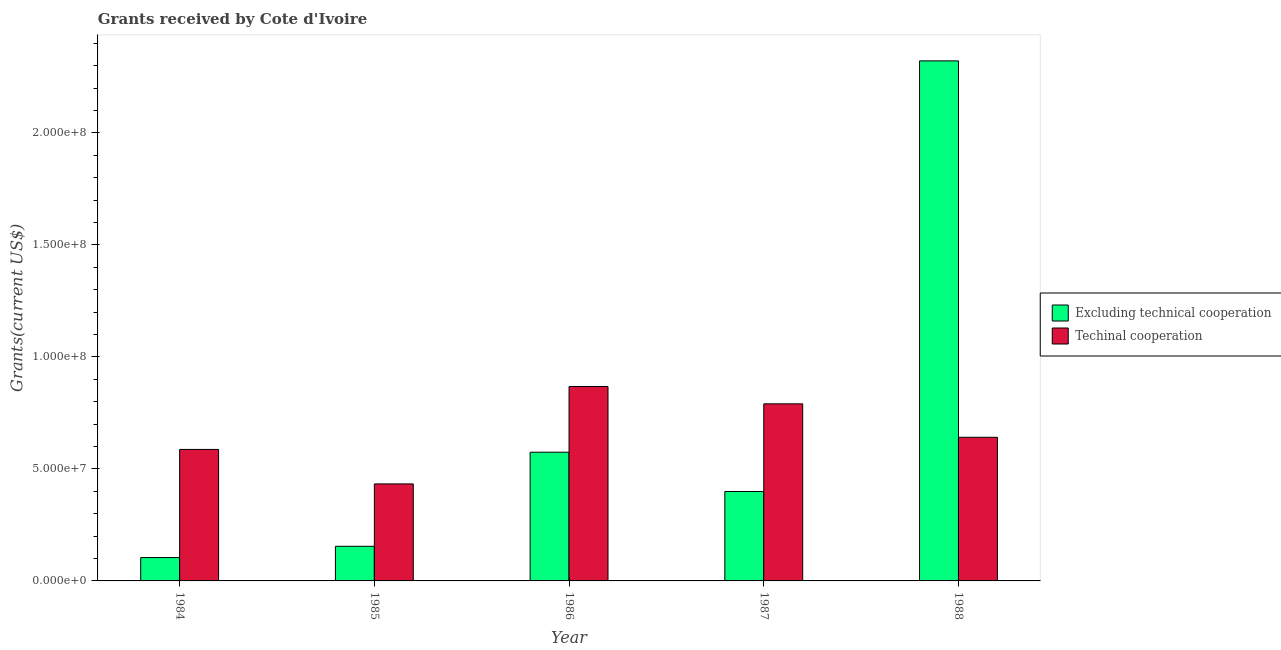How many different coloured bars are there?
Your answer should be compact. 2. How many groups of bars are there?
Your response must be concise. 5. Are the number of bars per tick equal to the number of legend labels?
Ensure brevity in your answer.  Yes. How many bars are there on the 2nd tick from the left?
Give a very brief answer. 2. How many bars are there on the 3rd tick from the right?
Provide a short and direct response. 2. In how many cases, is the number of bars for a given year not equal to the number of legend labels?
Offer a very short reply. 0. What is the amount of grants received(including technical cooperation) in 1985?
Make the answer very short. 4.33e+07. Across all years, what is the maximum amount of grants received(including technical cooperation)?
Ensure brevity in your answer.  8.68e+07. Across all years, what is the minimum amount of grants received(including technical cooperation)?
Give a very brief answer. 4.33e+07. In which year was the amount of grants received(excluding technical cooperation) minimum?
Offer a very short reply. 1984. What is the total amount of grants received(including technical cooperation) in the graph?
Your response must be concise. 3.32e+08. What is the difference between the amount of grants received(excluding technical cooperation) in 1987 and that in 1988?
Offer a terse response. -1.92e+08. What is the difference between the amount of grants received(including technical cooperation) in 1988 and the amount of grants received(excluding technical cooperation) in 1987?
Your response must be concise. -1.49e+07. What is the average amount of grants received(excluding technical cooperation) per year?
Make the answer very short. 7.11e+07. What is the ratio of the amount of grants received(excluding technical cooperation) in 1985 to that in 1986?
Offer a very short reply. 0.27. What is the difference between the highest and the second highest amount of grants received(including technical cooperation)?
Your response must be concise. 7.74e+06. What is the difference between the highest and the lowest amount of grants received(excluding technical cooperation)?
Ensure brevity in your answer.  2.22e+08. What does the 1st bar from the left in 1987 represents?
Give a very brief answer. Excluding technical cooperation. What does the 1st bar from the right in 1988 represents?
Provide a short and direct response. Techinal cooperation. How many bars are there?
Your answer should be compact. 10. Are all the bars in the graph horizontal?
Your answer should be compact. No. How many years are there in the graph?
Ensure brevity in your answer.  5. How are the legend labels stacked?
Ensure brevity in your answer.  Vertical. What is the title of the graph?
Give a very brief answer. Grants received by Cote d'Ivoire. Does "Resident workers" appear as one of the legend labels in the graph?
Give a very brief answer. No. What is the label or title of the X-axis?
Make the answer very short. Year. What is the label or title of the Y-axis?
Ensure brevity in your answer.  Grants(current US$). What is the Grants(current US$) in Excluding technical cooperation in 1984?
Ensure brevity in your answer.  1.04e+07. What is the Grants(current US$) of Techinal cooperation in 1984?
Make the answer very short. 5.87e+07. What is the Grants(current US$) of Excluding technical cooperation in 1985?
Provide a succinct answer. 1.55e+07. What is the Grants(current US$) in Techinal cooperation in 1985?
Make the answer very short. 4.33e+07. What is the Grants(current US$) of Excluding technical cooperation in 1986?
Offer a very short reply. 5.74e+07. What is the Grants(current US$) in Techinal cooperation in 1986?
Keep it short and to the point. 8.68e+07. What is the Grants(current US$) in Excluding technical cooperation in 1987?
Your answer should be compact. 3.99e+07. What is the Grants(current US$) of Techinal cooperation in 1987?
Your response must be concise. 7.90e+07. What is the Grants(current US$) in Excluding technical cooperation in 1988?
Your answer should be compact. 2.32e+08. What is the Grants(current US$) in Techinal cooperation in 1988?
Make the answer very short. 6.41e+07. Across all years, what is the maximum Grants(current US$) of Excluding technical cooperation?
Offer a very short reply. 2.32e+08. Across all years, what is the maximum Grants(current US$) in Techinal cooperation?
Your response must be concise. 8.68e+07. Across all years, what is the minimum Grants(current US$) in Excluding technical cooperation?
Your answer should be compact. 1.04e+07. Across all years, what is the minimum Grants(current US$) in Techinal cooperation?
Your response must be concise. 4.33e+07. What is the total Grants(current US$) of Excluding technical cooperation in the graph?
Provide a succinct answer. 3.55e+08. What is the total Grants(current US$) in Techinal cooperation in the graph?
Your answer should be very brief. 3.32e+08. What is the difference between the Grants(current US$) in Excluding technical cooperation in 1984 and that in 1985?
Make the answer very short. -5.03e+06. What is the difference between the Grants(current US$) in Techinal cooperation in 1984 and that in 1985?
Your answer should be very brief. 1.54e+07. What is the difference between the Grants(current US$) of Excluding technical cooperation in 1984 and that in 1986?
Offer a very short reply. -4.70e+07. What is the difference between the Grants(current US$) in Techinal cooperation in 1984 and that in 1986?
Offer a very short reply. -2.81e+07. What is the difference between the Grants(current US$) in Excluding technical cooperation in 1984 and that in 1987?
Your response must be concise. -2.95e+07. What is the difference between the Grants(current US$) in Techinal cooperation in 1984 and that in 1987?
Your answer should be very brief. -2.04e+07. What is the difference between the Grants(current US$) in Excluding technical cooperation in 1984 and that in 1988?
Offer a terse response. -2.22e+08. What is the difference between the Grants(current US$) of Techinal cooperation in 1984 and that in 1988?
Offer a very short reply. -5.42e+06. What is the difference between the Grants(current US$) of Excluding technical cooperation in 1985 and that in 1986?
Make the answer very short. -4.20e+07. What is the difference between the Grants(current US$) in Techinal cooperation in 1985 and that in 1986?
Ensure brevity in your answer.  -4.35e+07. What is the difference between the Grants(current US$) of Excluding technical cooperation in 1985 and that in 1987?
Offer a terse response. -2.45e+07. What is the difference between the Grants(current US$) in Techinal cooperation in 1985 and that in 1987?
Your answer should be compact. -3.57e+07. What is the difference between the Grants(current US$) in Excluding technical cooperation in 1985 and that in 1988?
Offer a very short reply. -2.17e+08. What is the difference between the Grants(current US$) of Techinal cooperation in 1985 and that in 1988?
Provide a succinct answer. -2.08e+07. What is the difference between the Grants(current US$) of Excluding technical cooperation in 1986 and that in 1987?
Ensure brevity in your answer.  1.75e+07. What is the difference between the Grants(current US$) of Techinal cooperation in 1986 and that in 1987?
Ensure brevity in your answer.  7.74e+06. What is the difference between the Grants(current US$) of Excluding technical cooperation in 1986 and that in 1988?
Your answer should be compact. -1.75e+08. What is the difference between the Grants(current US$) of Techinal cooperation in 1986 and that in 1988?
Keep it short and to the point. 2.27e+07. What is the difference between the Grants(current US$) in Excluding technical cooperation in 1987 and that in 1988?
Keep it short and to the point. -1.92e+08. What is the difference between the Grants(current US$) of Techinal cooperation in 1987 and that in 1988?
Your answer should be compact. 1.49e+07. What is the difference between the Grants(current US$) of Excluding technical cooperation in 1984 and the Grants(current US$) of Techinal cooperation in 1985?
Your response must be concise. -3.29e+07. What is the difference between the Grants(current US$) of Excluding technical cooperation in 1984 and the Grants(current US$) of Techinal cooperation in 1986?
Keep it short and to the point. -7.64e+07. What is the difference between the Grants(current US$) of Excluding technical cooperation in 1984 and the Grants(current US$) of Techinal cooperation in 1987?
Provide a short and direct response. -6.86e+07. What is the difference between the Grants(current US$) of Excluding technical cooperation in 1984 and the Grants(current US$) of Techinal cooperation in 1988?
Provide a succinct answer. -5.37e+07. What is the difference between the Grants(current US$) of Excluding technical cooperation in 1985 and the Grants(current US$) of Techinal cooperation in 1986?
Your response must be concise. -7.13e+07. What is the difference between the Grants(current US$) of Excluding technical cooperation in 1985 and the Grants(current US$) of Techinal cooperation in 1987?
Your answer should be very brief. -6.36e+07. What is the difference between the Grants(current US$) of Excluding technical cooperation in 1985 and the Grants(current US$) of Techinal cooperation in 1988?
Make the answer very short. -4.86e+07. What is the difference between the Grants(current US$) in Excluding technical cooperation in 1986 and the Grants(current US$) in Techinal cooperation in 1987?
Offer a terse response. -2.16e+07. What is the difference between the Grants(current US$) in Excluding technical cooperation in 1986 and the Grants(current US$) in Techinal cooperation in 1988?
Offer a very short reply. -6.66e+06. What is the difference between the Grants(current US$) in Excluding technical cooperation in 1987 and the Grants(current US$) in Techinal cooperation in 1988?
Keep it short and to the point. -2.42e+07. What is the average Grants(current US$) in Excluding technical cooperation per year?
Offer a terse response. 7.11e+07. What is the average Grants(current US$) in Techinal cooperation per year?
Provide a succinct answer. 6.64e+07. In the year 1984, what is the difference between the Grants(current US$) of Excluding technical cooperation and Grants(current US$) of Techinal cooperation?
Your answer should be compact. -4.83e+07. In the year 1985, what is the difference between the Grants(current US$) in Excluding technical cooperation and Grants(current US$) in Techinal cooperation?
Your response must be concise. -2.78e+07. In the year 1986, what is the difference between the Grants(current US$) in Excluding technical cooperation and Grants(current US$) in Techinal cooperation?
Provide a short and direct response. -2.93e+07. In the year 1987, what is the difference between the Grants(current US$) in Excluding technical cooperation and Grants(current US$) in Techinal cooperation?
Offer a terse response. -3.91e+07. In the year 1988, what is the difference between the Grants(current US$) in Excluding technical cooperation and Grants(current US$) in Techinal cooperation?
Offer a very short reply. 1.68e+08. What is the ratio of the Grants(current US$) of Excluding technical cooperation in 1984 to that in 1985?
Provide a succinct answer. 0.67. What is the ratio of the Grants(current US$) in Techinal cooperation in 1984 to that in 1985?
Keep it short and to the point. 1.36. What is the ratio of the Grants(current US$) in Excluding technical cooperation in 1984 to that in 1986?
Give a very brief answer. 0.18. What is the ratio of the Grants(current US$) in Techinal cooperation in 1984 to that in 1986?
Your response must be concise. 0.68. What is the ratio of the Grants(current US$) in Excluding technical cooperation in 1984 to that in 1987?
Provide a short and direct response. 0.26. What is the ratio of the Grants(current US$) of Techinal cooperation in 1984 to that in 1987?
Make the answer very short. 0.74. What is the ratio of the Grants(current US$) of Excluding technical cooperation in 1984 to that in 1988?
Offer a terse response. 0.04. What is the ratio of the Grants(current US$) of Techinal cooperation in 1984 to that in 1988?
Provide a short and direct response. 0.92. What is the ratio of the Grants(current US$) of Excluding technical cooperation in 1985 to that in 1986?
Give a very brief answer. 0.27. What is the ratio of the Grants(current US$) in Techinal cooperation in 1985 to that in 1986?
Provide a succinct answer. 0.5. What is the ratio of the Grants(current US$) of Excluding technical cooperation in 1985 to that in 1987?
Ensure brevity in your answer.  0.39. What is the ratio of the Grants(current US$) of Techinal cooperation in 1985 to that in 1987?
Your answer should be compact. 0.55. What is the ratio of the Grants(current US$) in Excluding technical cooperation in 1985 to that in 1988?
Offer a terse response. 0.07. What is the ratio of the Grants(current US$) of Techinal cooperation in 1985 to that in 1988?
Provide a short and direct response. 0.68. What is the ratio of the Grants(current US$) in Excluding technical cooperation in 1986 to that in 1987?
Give a very brief answer. 1.44. What is the ratio of the Grants(current US$) in Techinal cooperation in 1986 to that in 1987?
Your answer should be very brief. 1.1. What is the ratio of the Grants(current US$) of Excluding technical cooperation in 1986 to that in 1988?
Your answer should be compact. 0.25. What is the ratio of the Grants(current US$) of Techinal cooperation in 1986 to that in 1988?
Provide a succinct answer. 1.35. What is the ratio of the Grants(current US$) in Excluding technical cooperation in 1987 to that in 1988?
Your answer should be very brief. 0.17. What is the ratio of the Grants(current US$) of Techinal cooperation in 1987 to that in 1988?
Your answer should be very brief. 1.23. What is the difference between the highest and the second highest Grants(current US$) in Excluding technical cooperation?
Provide a succinct answer. 1.75e+08. What is the difference between the highest and the second highest Grants(current US$) in Techinal cooperation?
Your response must be concise. 7.74e+06. What is the difference between the highest and the lowest Grants(current US$) of Excluding technical cooperation?
Provide a short and direct response. 2.22e+08. What is the difference between the highest and the lowest Grants(current US$) of Techinal cooperation?
Your response must be concise. 4.35e+07. 